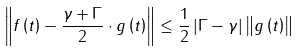<formula> <loc_0><loc_0><loc_500><loc_500>\left \| f \left ( t \right ) - \frac { \gamma + \Gamma } { 2 } \cdot g \left ( t \right ) \right \| \leq \frac { 1 } { 2 } \left | \Gamma - \gamma \right | \left \| g \left ( t \right ) \right \|</formula> 